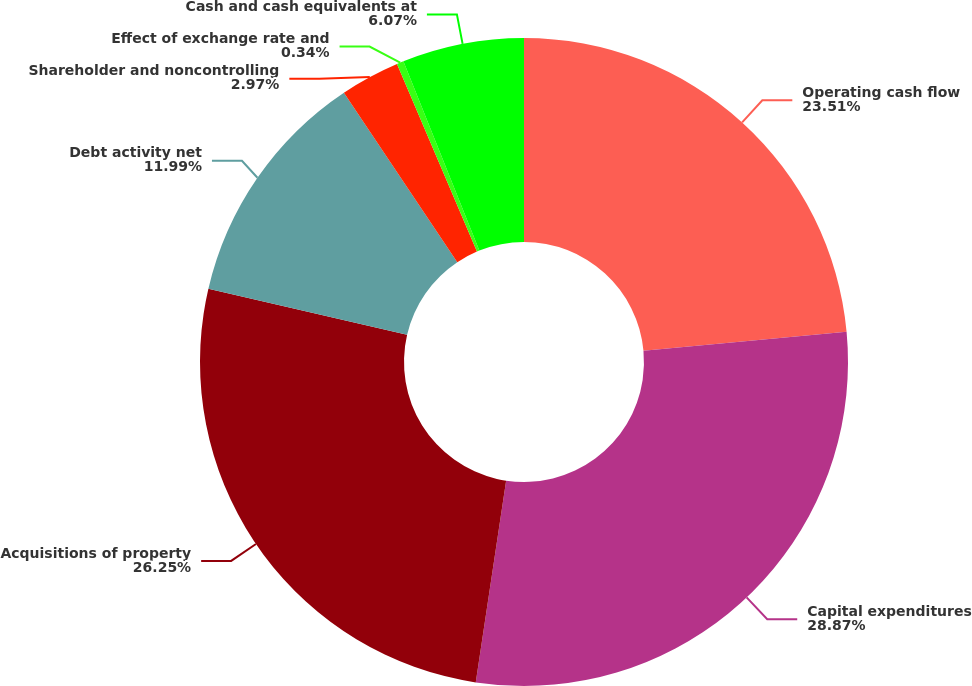Convert chart to OTSL. <chart><loc_0><loc_0><loc_500><loc_500><pie_chart><fcel>Operating cash flow<fcel>Capital expenditures<fcel>Acquisitions of property<fcel>Debt activity net<fcel>Shareholder and noncontrolling<fcel>Effect of exchange rate and<fcel>Cash and cash equivalents at<nl><fcel>23.51%<fcel>28.87%<fcel>26.25%<fcel>11.99%<fcel>2.97%<fcel>0.34%<fcel>6.07%<nl></chart> 